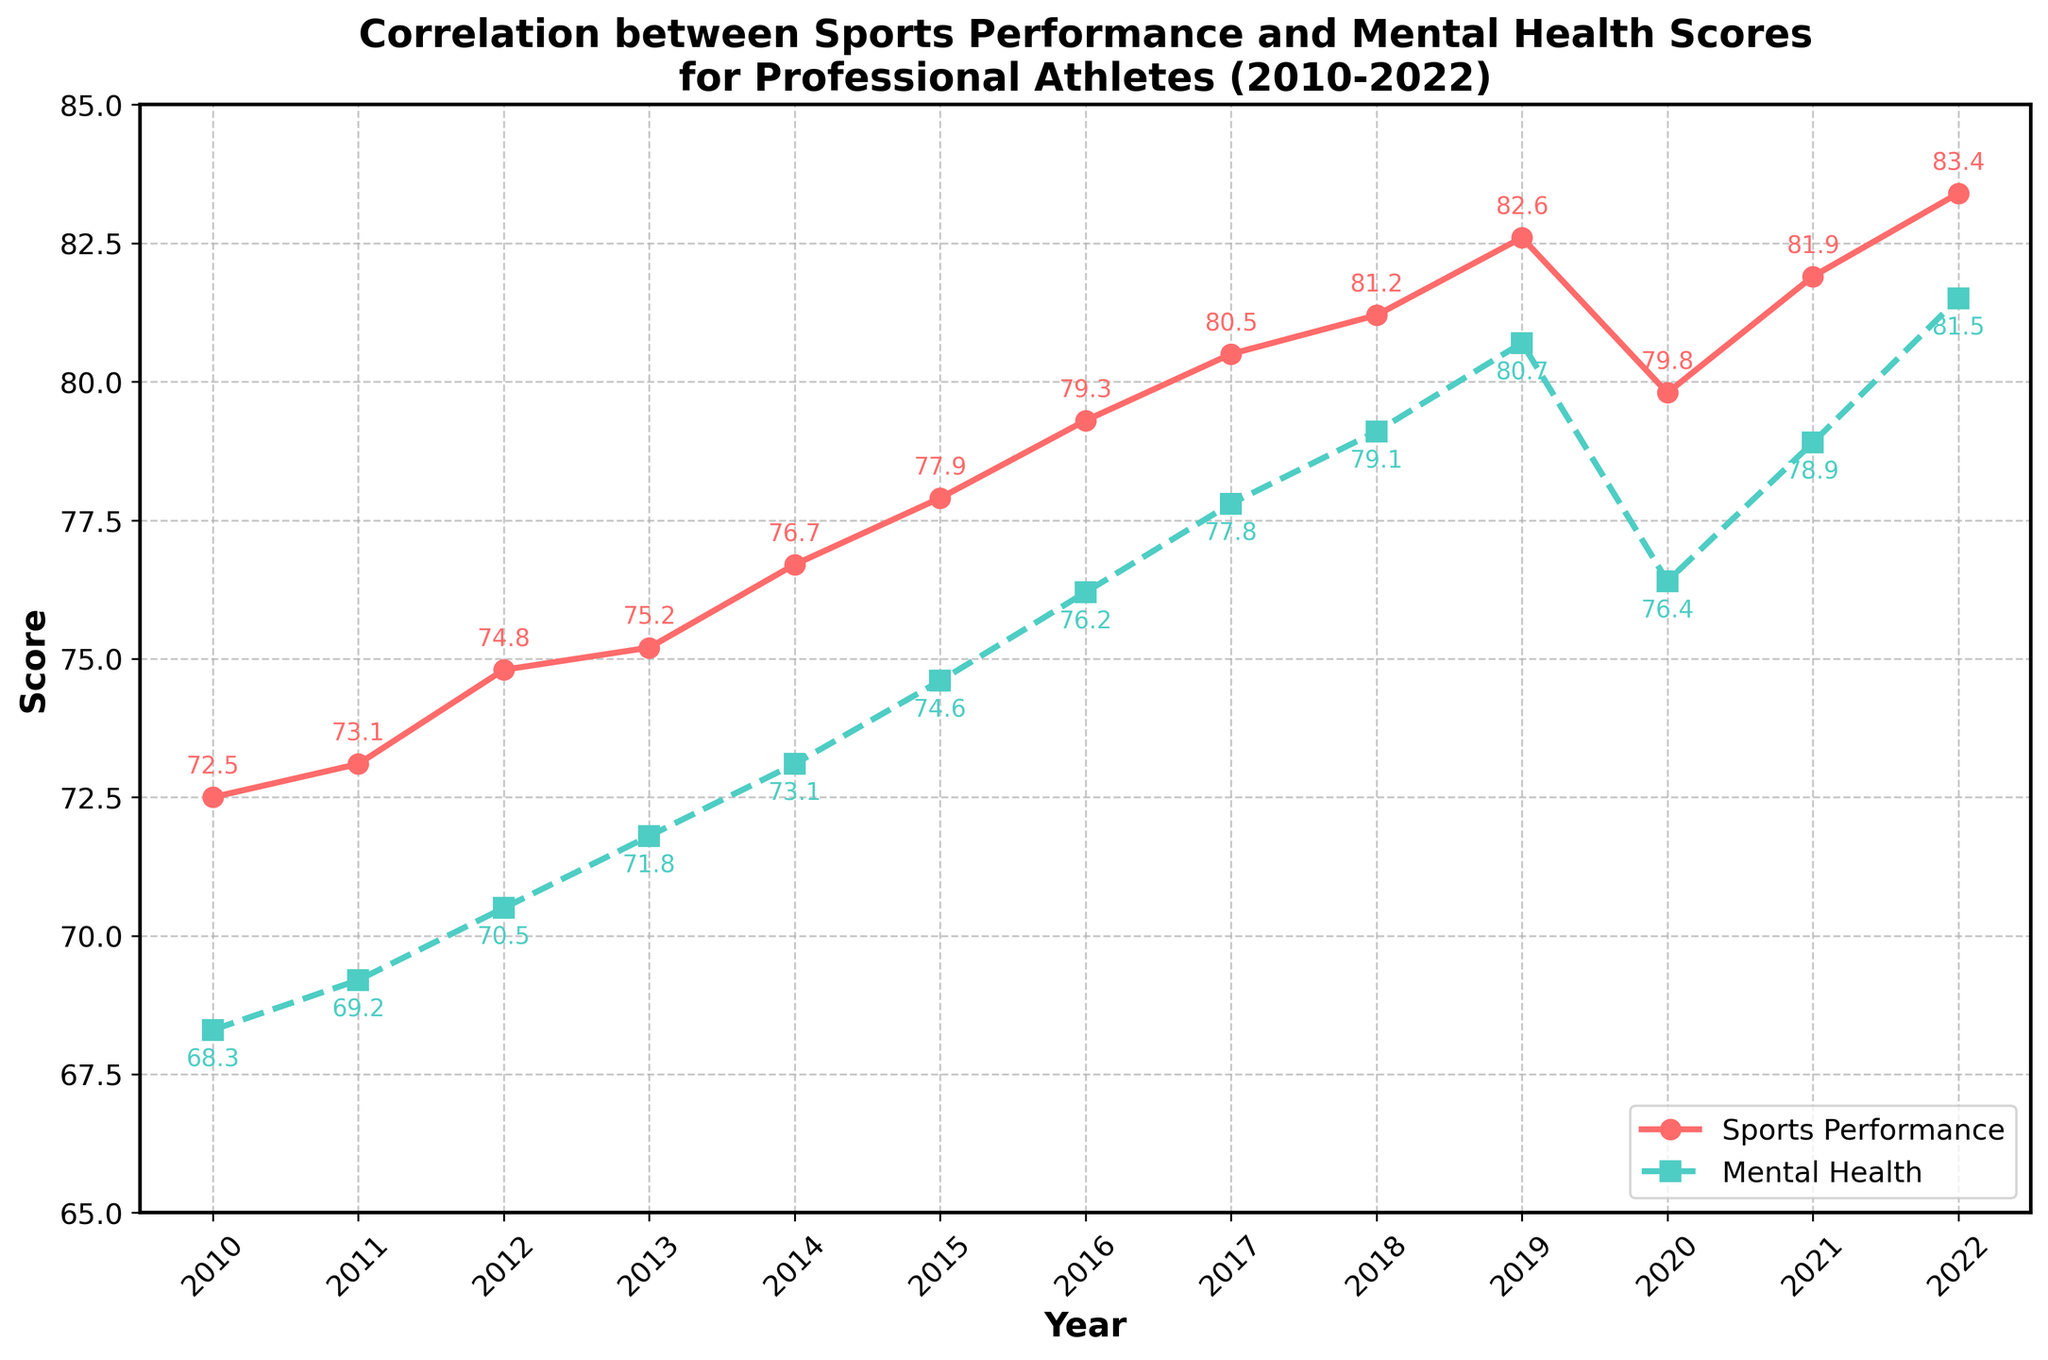What's the general trend between 2010 and 2022 for both sports performance and mental health scores? To determine the trend, observe the movement of the lines from 2010 to 2022. Both lines generally slope upwards over the years, indicating that both sports performance and mental health scores have improved over time, except for a slight dip in 2020.
Answer: Both scores generally increased over time In which year did both sports performance and mental health scores experience a noticeable decline? Identify where both lines dip together. In 2020, both the sports performance and mental health scores decline compared to previous years.
Answer: 2020 What is the difference in sports performance scores between 2010 and 2022? To calculate the difference, subtract the 2010 sports performance score from the 2022 score: 83.4 - 72.5.
Answer: 10.9 Which year saw the largest increase in mental health scores compared to the previous year? Examine the year-over-year changes in mental health scores and find the largest difference. The difference between 2019 (80.7) and 2020 (76.4) represents a decrease, and the next significant increase happens between 2020 and 2021 where the score increased from 76.4 to 78.9.
Answer: 2021 Compare the sports performance and mental health scores for the year 2015. Which one was higher and by how much? Look at the scores for 2015: sports performance is 77.9, and mental health is 74.6. Subtract the smaller score from the bigger one to find the difference.
Answer: Sports performance was higher by 3.3 What is the average sports performance score over the period 2010-2022? Sum all the sports performance scores and divide by the number of years (13). (72.5 + 73.1 + 74.8 + 75.2 + 76.7 + 77.9 + 79.3 + 80.5 + 81.2 + 82.6 + 79.8 + 81.9 + 83.4) / 13 = 78.1
Answer: 78.1 Did the sports performance score ever surpass 80 before 2017? Check the sports performance scores for the years before 2017. None of the scores surpass 80 before 2017.
Answer: No By how much did the sports performance score increase from 2017 to 2019? Identify the scores for 2017 (80.5) and 2019 (82.6), then calculate the difference: 82.6 - 80.5.
Answer: 2.1 How do the slopes of the lines between 2019 and 2020 compare for both sports performance and mental health scores? Compare the steepness of the line segments from 2019 to 2020. Both lines slope downward, but the mental health score's slope appears steeper.
Answer: Mental health score has a steeper decrease 